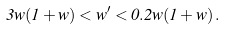<formula> <loc_0><loc_0><loc_500><loc_500>3 w ( 1 + w ) < w ^ { \prime } < 0 . 2 w ( 1 + w ) \, .</formula> 